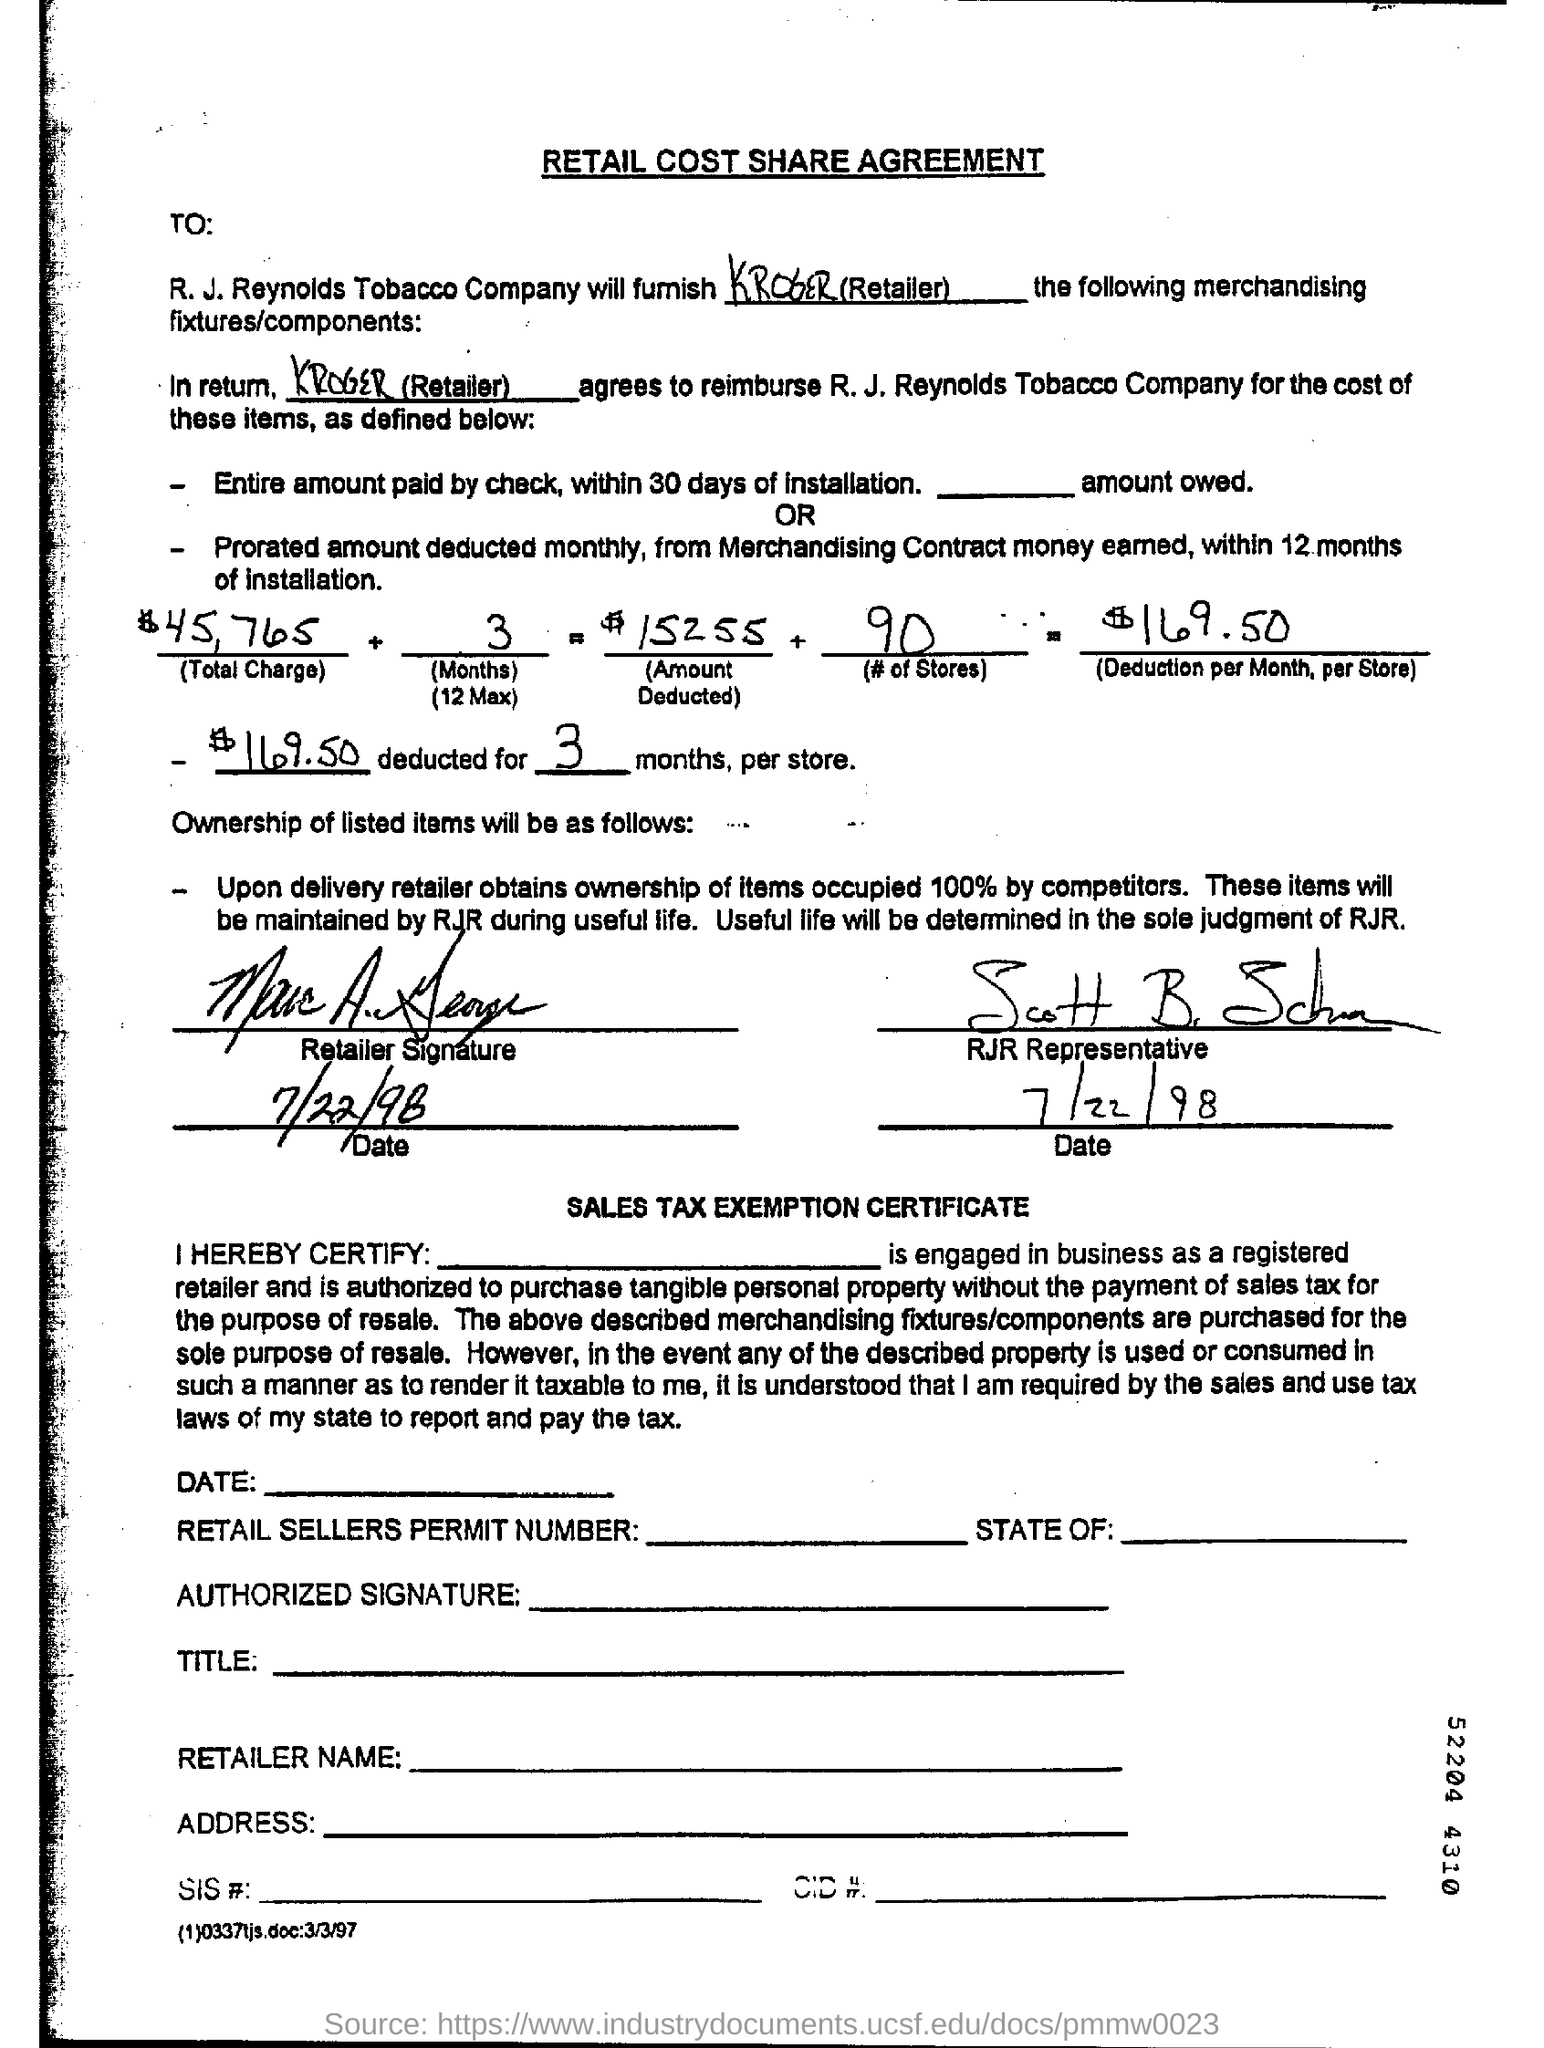Outline some significant characteristics in this image. The retailer is Kroger. The heading at the top of the page reads 'Retail cost share agreement.' The deduction amount per month, per store, is $169.50. The number of stores is 90. 